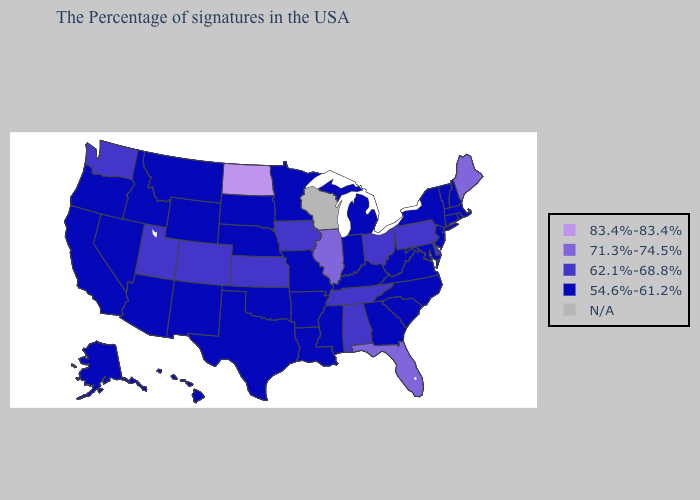Among the states that border New Jersey , which have the highest value?
Keep it brief. Delaware, Pennsylvania. What is the lowest value in the Northeast?
Keep it brief. 54.6%-61.2%. What is the value of Idaho?
Short answer required. 54.6%-61.2%. Does the first symbol in the legend represent the smallest category?
Short answer required. No. What is the lowest value in states that border Nevada?
Short answer required. 54.6%-61.2%. What is the value of New Jersey?
Short answer required. 54.6%-61.2%. Which states hav the highest value in the South?
Write a very short answer. Florida. What is the value of Florida?
Give a very brief answer. 71.3%-74.5%. What is the value of New Hampshire?
Write a very short answer. 54.6%-61.2%. What is the value of New York?
Keep it brief. 54.6%-61.2%. Name the states that have a value in the range N/A?
Quick response, please. Wisconsin. Is the legend a continuous bar?
Keep it brief. No. Name the states that have a value in the range 83.4%-83.4%?
Give a very brief answer. North Dakota. Which states hav the highest value in the MidWest?
Write a very short answer. North Dakota. 